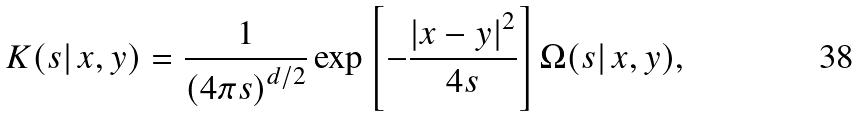Convert formula to latex. <formula><loc_0><loc_0><loc_500><loc_500>K ( s | \, x , y ) = \frac { 1 } { \left ( 4 \pi s \right ) ^ { d / 2 } } \exp \left [ - \frac { \left | x - y \right | ^ { 2 } } { 4 s } \right ] \Omega ( s | \, x , y ) ,</formula> 